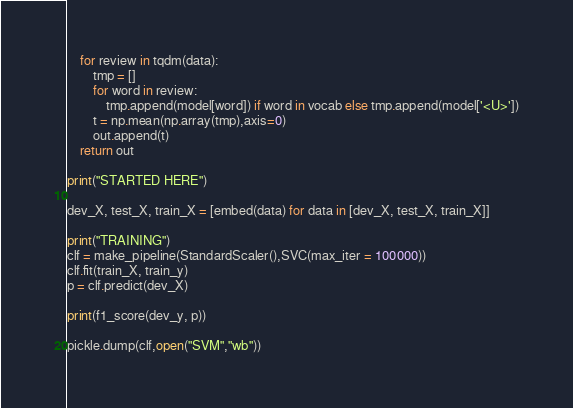<code> <loc_0><loc_0><loc_500><loc_500><_Python_>    for review in tqdm(data):
        tmp = []
        for word in review:
            tmp.append(model[word]) if word in vocab else tmp.append(model['<U>'])
        t = np.mean(np.array(tmp),axis=0)
        out.append(t)
    return out

print("STARTED HERE")

dev_X, test_X, train_X = [embed(data) for data in [dev_X, test_X, train_X]]

print("TRAINING")
clf = make_pipeline(StandardScaler(),SVC(max_iter = 100000))
clf.fit(train_X, train_y)
p = clf.predict(dev_X)

print(f1_score(dev_y, p))

pickle.dump(clf,open("SVM","wb"))
</code> 